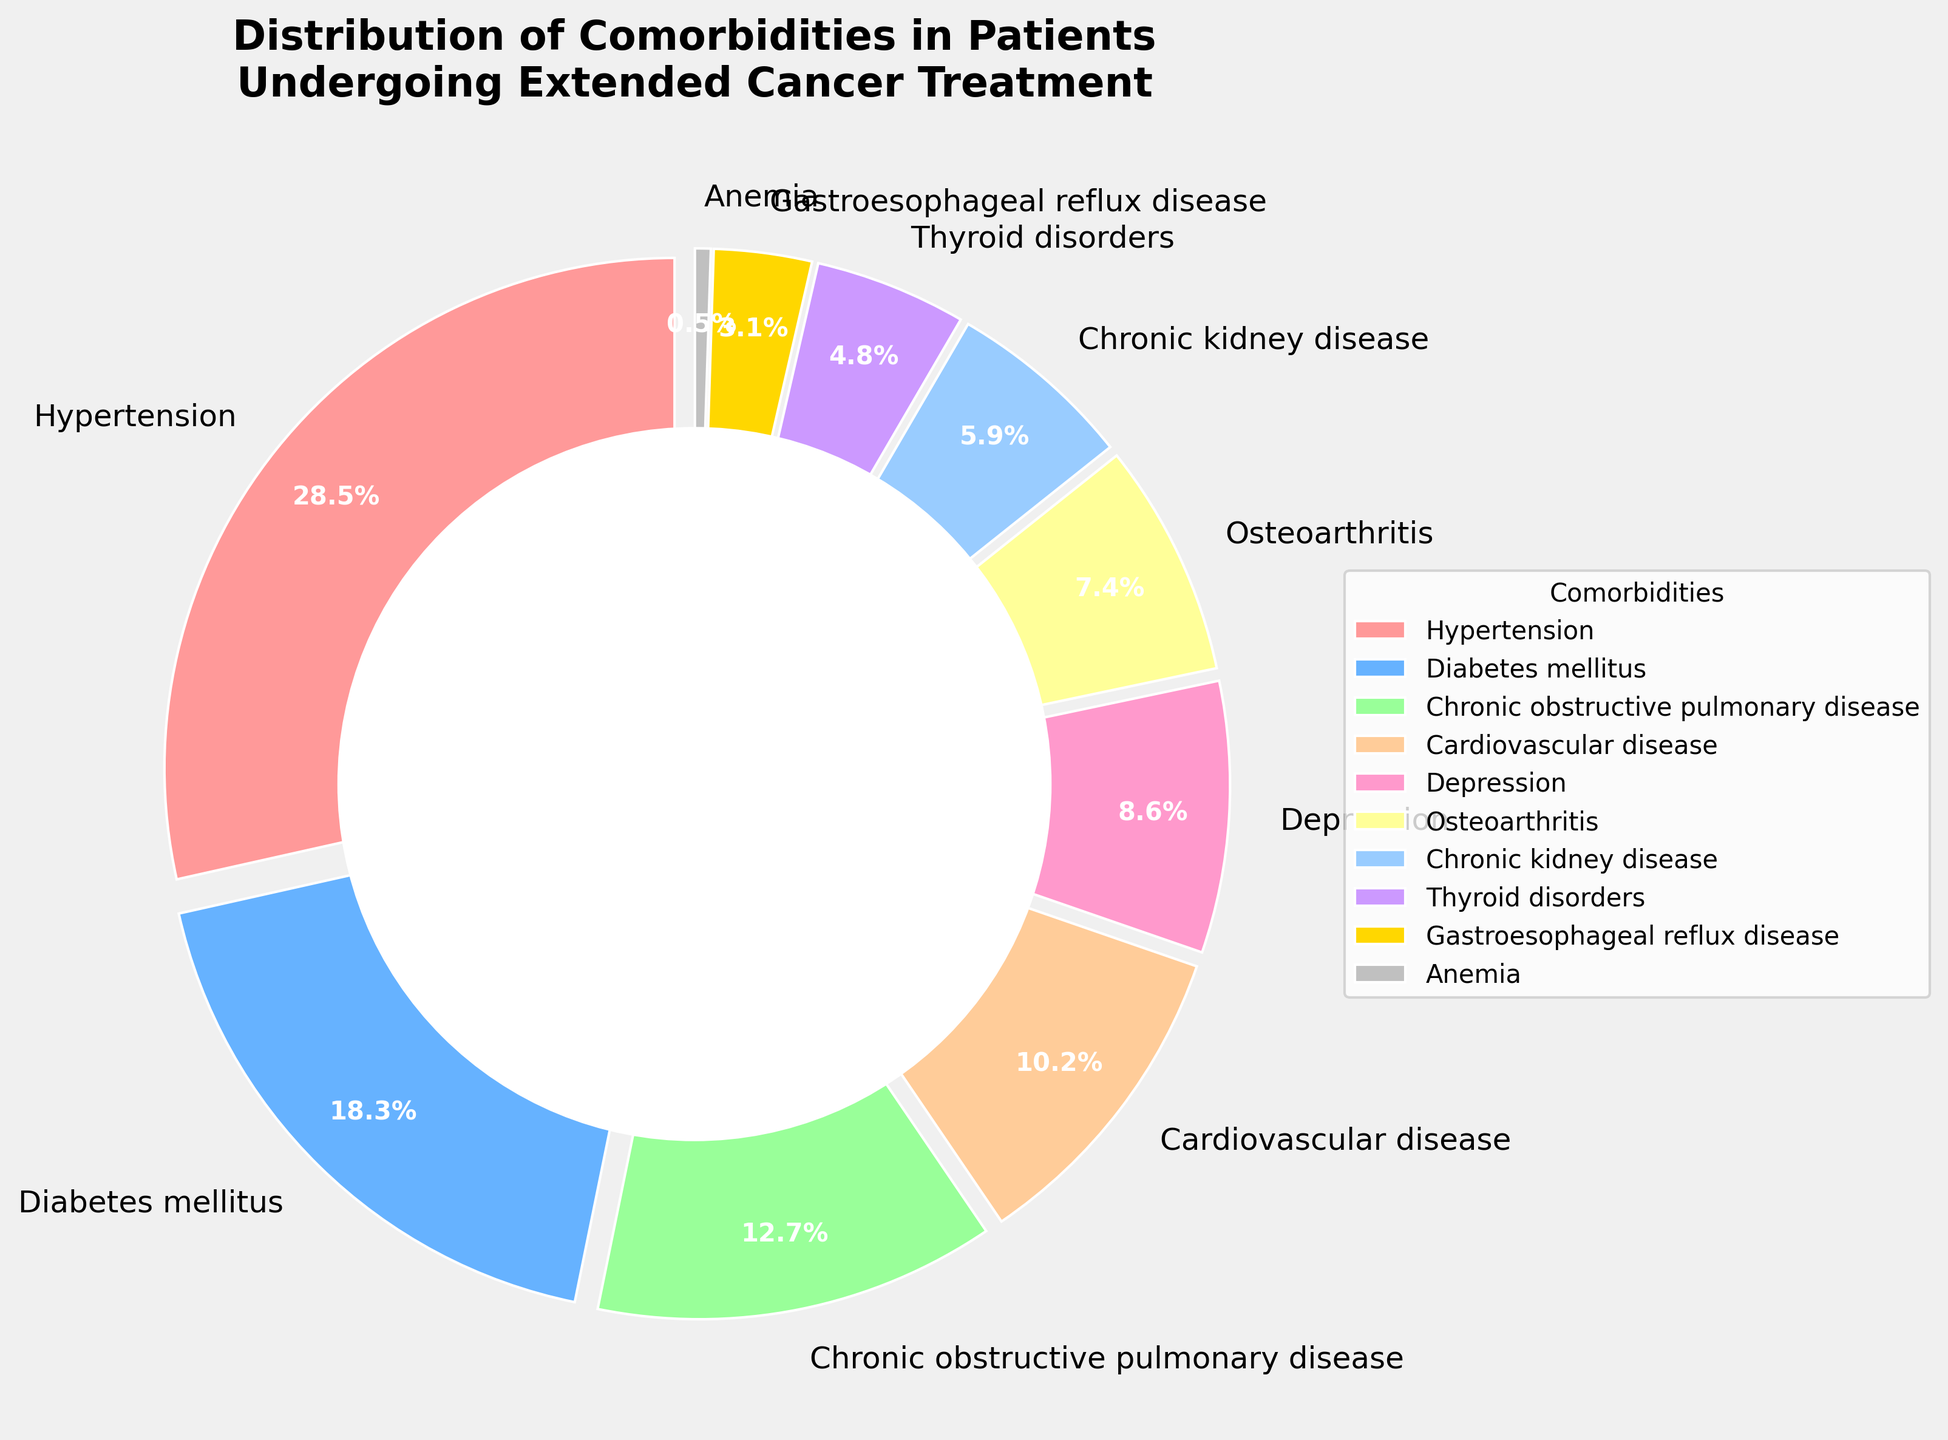What comorbidity has the highest percentage? By looking at the pie chart, the comorbidity with the largest slice represents the highest percentage. The largest slice is labeled as 'Hypertension'.
Answer: Hypertension Which three comorbidities have the lowest percentages? By examining the pie chart, we can find the three smallest slices. These are labeled 'Anemia', 'Gastroesophageal reflux disease', and 'Thyroid disorders'.
Answer: Anemia, Gastroesophageal reflux disease, Thyroid disorders What is the combined percentage of patients with Diabetes mellitus and Depression? The slice for Diabetes mellitus is labeled as 18.3%, and the slice for Depression is labeled as 8.6%. Summing these percentages: 18.3% + 8.6% = 26.9%.
Answer: 26.9% How much larger is the percentage of patients with Hypertension compared to those with Cardiovascular disease? The percentage for Hypertension is 28.5%, and for Cardiovascular disease, it is 10.2%. Subtracting these: 28.5% - 10.2% = 18.3%.
Answer: 18.3% Which color represents Chronic obstructive pulmonary disease on the pie chart? By referencing the specific color scheme used in the pie chart, the slice labeled as 'Chronic obstructive pulmonary disease' is colored with a light blue.
Answer: Light blue Is the percentage of patients with Chronic kidney disease higher than those with Osteoarthritis? The slice for Chronic kidney disease is labeled as 5.9%, and for Osteoarthritis, it is labeled as 7.4%. Since 5.9% < 7.4%, Chronic kidney disease is not higher.
Answer: No What is the difference in percentage between Chronic obstructive pulmonary disease and Thyroid disorders? The percentage for Chronic obstructive pulmonary disease is 12.7%, and for Thyroid disorders, it is 4.8%. Subtracting these: 12.7% - 4.8% = 7.9%.
Answer: 7.9% Which comorbidity's slice is directly adjacent to the slice for Gastroesophageal reflux disease? By observing the pie chart layout visually, the slices adjacent to Gastroesophageal reflux disease are 'Thyroid disorders' and 'Anemia'.
Answer: Thyroid disorders, Anemia What is the average percentage of the comorbidities labeled as Depression, Osteoarthritis, and Chronic kidney disease? The percentages are 8.6% (Depression), 7.4% (Osteoarthritis), and 5.9% (Chronic kidney disease). Summing these: 8.6% + 7.4% + 5.9% = 21.9%. Dividing by 3: 21.9% / 3 = 7.3%.
Answer: 7.3% Is the total percentage of patients with Hypertension, Diabetes mellitus, and Cardiovascular disease more than 50%? The percentages are 28.5% (Hypertension), 18.3% (Diabetes mellitus), and 10.2% (Cardiovascular disease). Summing these: 28.5% + 18.3% + 10.2% = 57%. Since 57% > 50%, the total is more than 50%.
Answer: Yes 